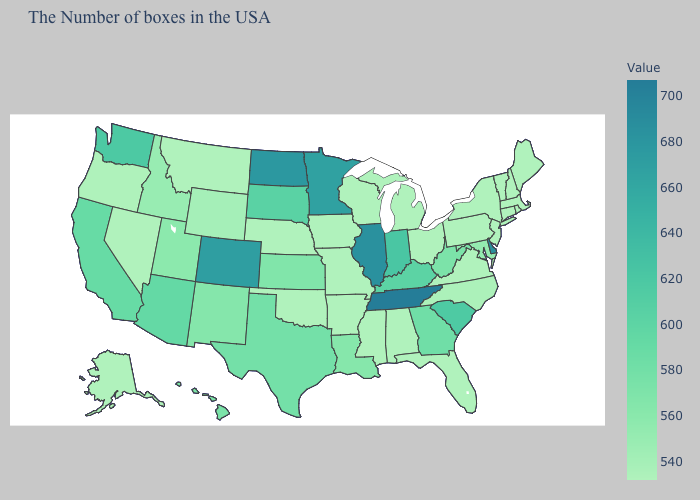Among the states that border New York , which have the lowest value?
Concise answer only. Massachusetts, Vermont, Connecticut, New Jersey, Pennsylvania. Which states have the highest value in the USA?
Short answer required. Tennessee. Which states have the highest value in the USA?
Give a very brief answer. Tennessee. Does Missouri have the lowest value in the USA?
Give a very brief answer. Yes. 